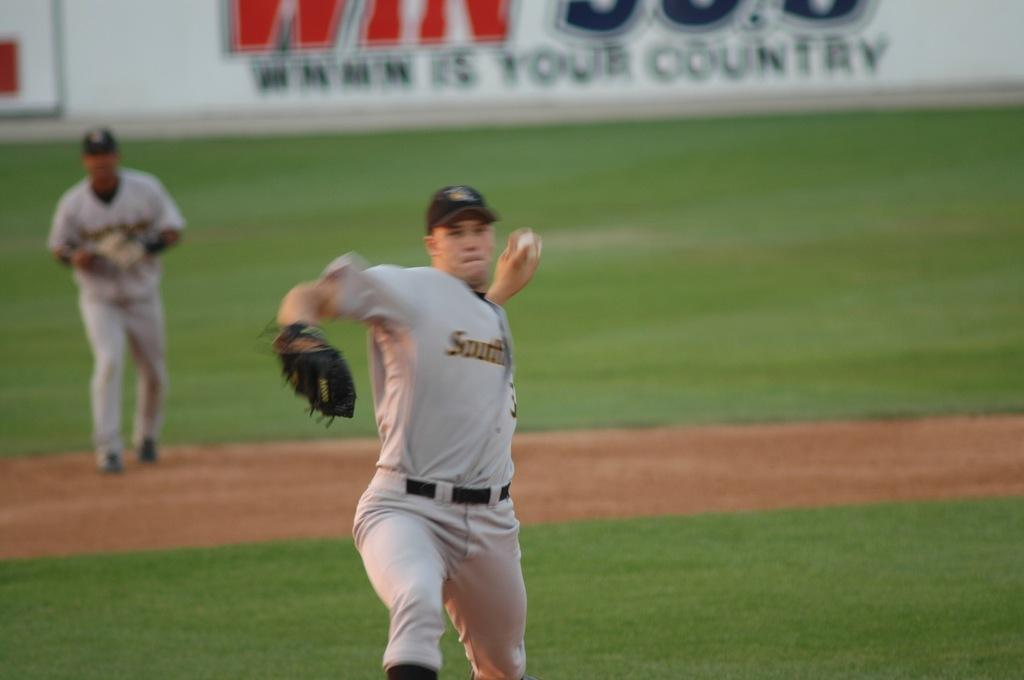Provide a one-sentence caption for the provided image. A pitcher wearing a jersey with the word South on the front throws a baseball. 